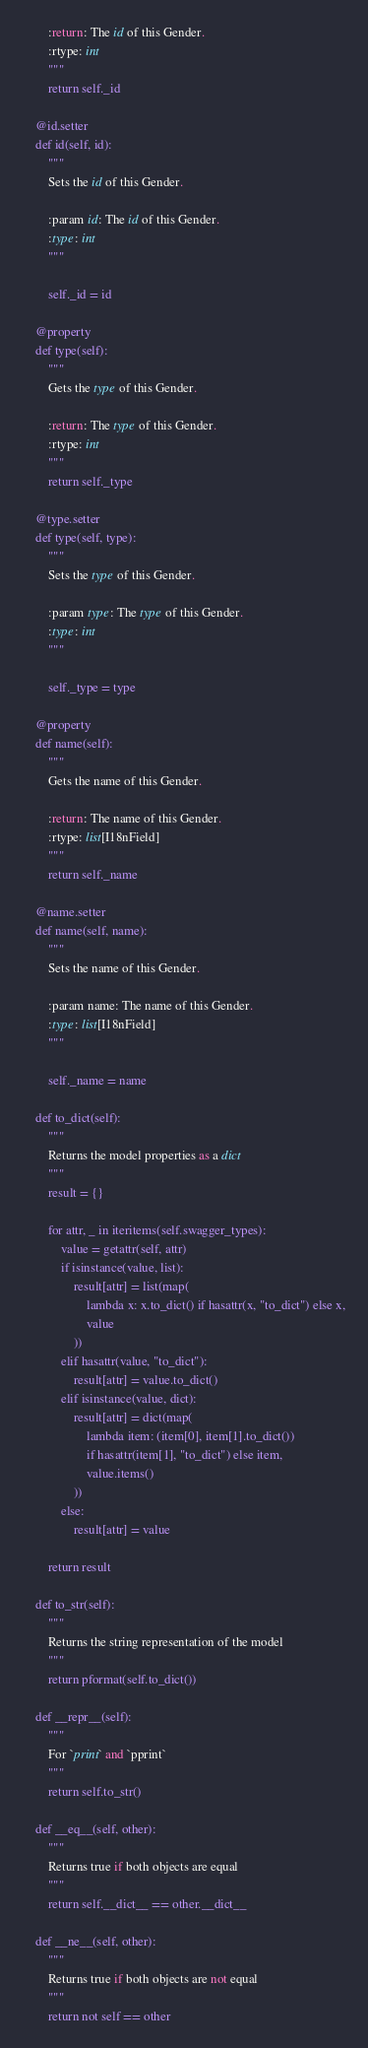Convert code to text. <code><loc_0><loc_0><loc_500><loc_500><_Python_>        :return: The id of this Gender.
        :rtype: int
        """
        return self._id

    @id.setter
    def id(self, id):
        """
        Sets the id of this Gender.

        :param id: The id of this Gender.
        :type: int
        """

        self._id = id

    @property
    def type(self):
        """
        Gets the type of this Gender.

        :return: The type of this Gender.
        :rtype: int
        """
        return self._type

    @type.setter
    def type(self, type):
        """
        Sets the type of this Gender.

        :param type: The type of this Gender.
        :type: int
        """

        self._type = type

    @property
    def name(self):
        """
        Gets the name of this Gender.

        :return: The name of this Gender.
        :rtype: list[I18nField]
        """
        return self._name

    @name.setter
    def name(self, name):
        """
        Sets the name of this Gender.

        :param name: The name of this Gender.
        :type: list[I18nField]
        """

        self._name = name

    def to_dict(self):
        """
        Returns the model properties as a dict
        """
        result = {}

        for attr, _ in iteritems(self.swagger_types):
            value = getattr(self, attr)
            if isinstance(value, list):
                result[attr] = list(map(
                    lambda x: x.to_dict() if hasattr(x, "to_dict") else x,
                    value
                ))
            elif hasattr(value, "to_dict"):
                result[attr] = value.to_dict()
            elif isinstance(value, dict):
                result[attr] = dict(map(
                    lambda item: (item[0], item[1].to_dict())
                    if hasattr(item[1], "to_dict") else item,
                    value.items()
                ))
            else:
                result[attr] = value

        return result

    def to_str(self):
        """
        Returns the string representation of the model
        """
        return pformat(self.to_dict())

    def __repr__(self):
        """
        For `print` and `pprint`
        """
        return self.to_str()

    def __eq__(self, other):
        """
        Returns true if both objects are equal
        """
        return self.__dict__ == other.__dict__

    def __ne__(self, other):
        """
        Returns true if both objects are not equal
        """
        return not self == other
</code> 